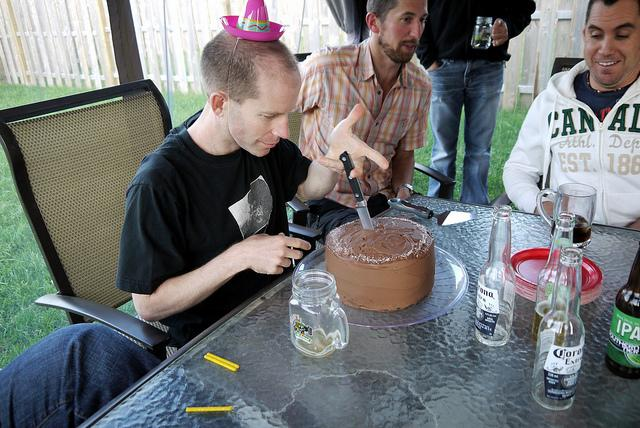What is in the cake? knife 